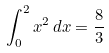Convert formula to latex. <formula><loc_0><loc_0><loc_500><loc_500>\int _ { 0 } ^ { 2 } x ^ { 2 } \, d x = { \frac { 8 } { 3 } }</formula> 